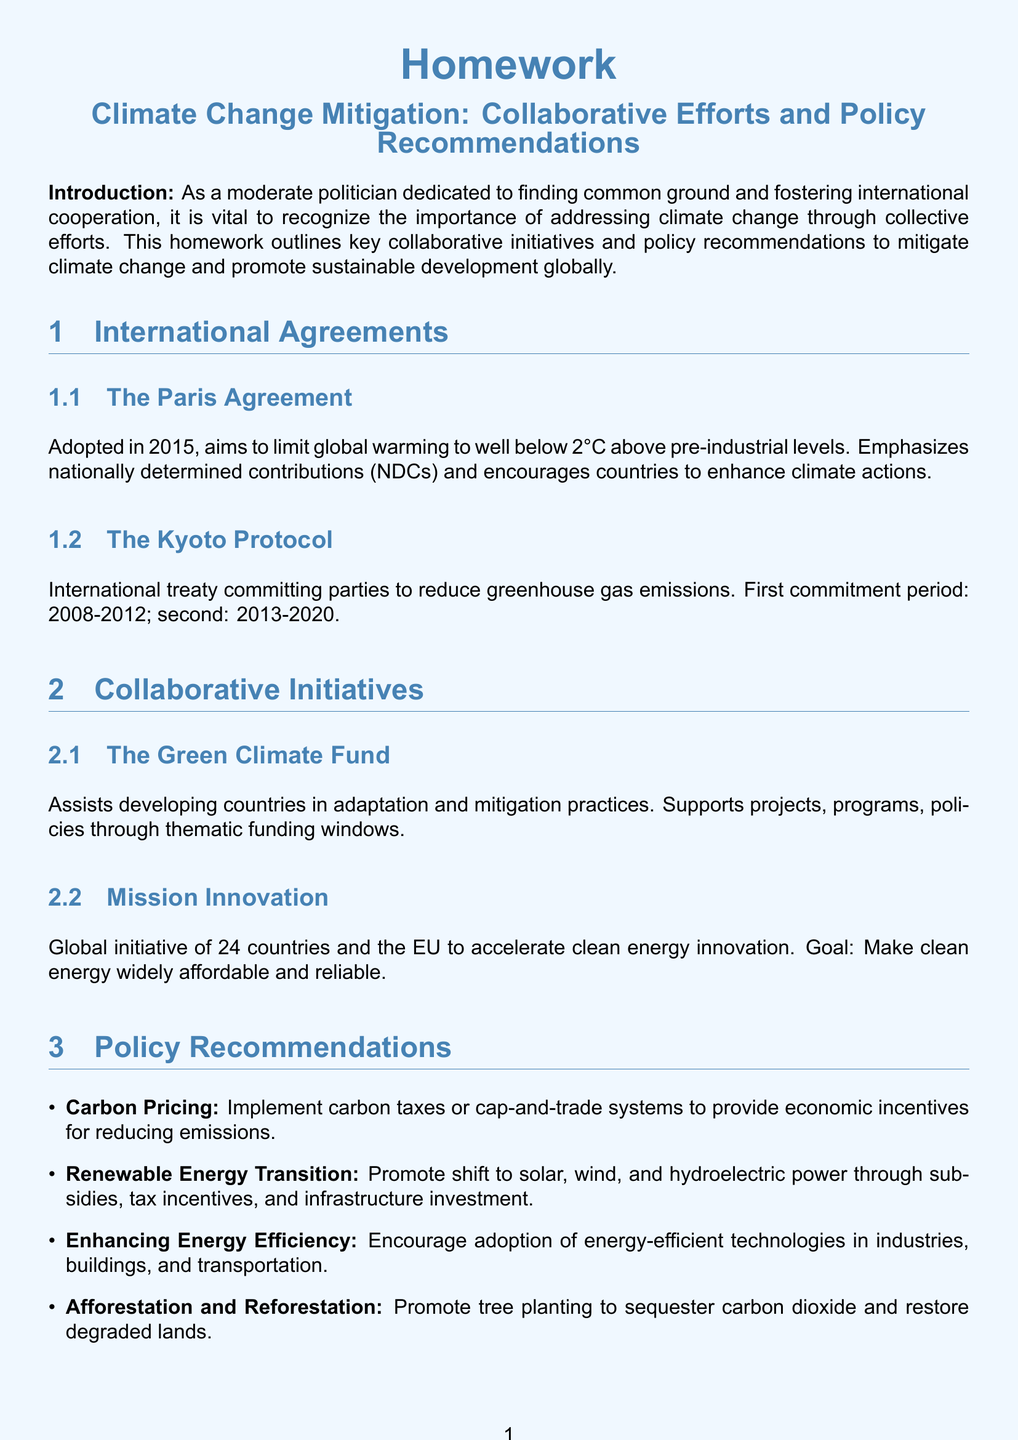What is the main goal of the Paris Agreement? The Paris Agreement aims to limit global warming to well below 2°C above pre-industrial levels.
Answer: limit global warming to well below 2°C When was the Kyoto Protocol first implemented? The document states the first commitment period of the Kyoto Protocol was 2008-2012.
Answer: 2008-2012 What is the purpose of the Green Climate Fund? The Green Climate Fund assists developing countries in adaptation and mitigation practices.
Answer: assist developing countries How many countries are involved in Mission Innovation? According to the document, Mission Innovation is a global initiative involving 24 countries and the EU.
Answer: 24 countries What are carbon pricing mechanisms mentioned? The document mentions carbon taxes or cap-and-trade systems.
Answer: carbon taxes or cap-and-trade systems What is one of the policy recommendations related to energy? One of the policy recommendations promotes a shift to solar, wind, and hydroelectric power.
Answer: shift to solar, wind, and hydroelectric power Which initiative supports projects through thematic funding windows? The document cites the Green Climate Fund supports projects through thematic funding windows.
Answer: The Green Climate Fund What is the role of afforestation in climate change mitigation? The document states that afforestation promotes tree planting to sequester carbon dioxide.
Answer: sequester carbon dioxide 